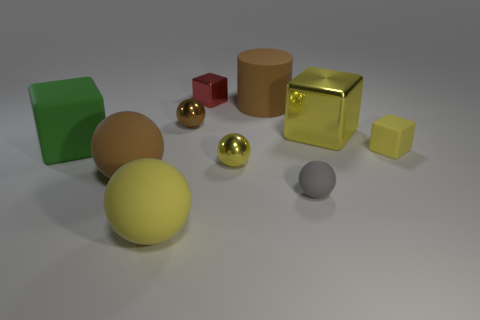Do the large shiny thing and the small rubber block have the same color?
Ensure brevity in your answer.  Yes. There is a brown ball in front of the large green cube; does it have the same size as the brown sphere that is behind the tiny yellow matte thing?
Your answer should be very brief. No. The large block that is on the left side of the small metallic cube is what color?
Provide a succinct answer. Green. What is the material of the large yellow object that is behind the yellow object that is to the left of the red thing?
Provide a succinct answer. Metal. The big metallic object has what shape?
Provide a succinct answer. Cube. What is the material of the small yellow thing that is the same shape as the big green rubber thing?
Your answer should be compact. Rubber. What number of metallic objects have the same size as the brown matte cylinder?
Offer a very short reply. 1. There is a yellow thing that is left of the small brown metallic ball; is there a rubber thing that is to the right of it?
Offer a terse response. Yes. What number of red objects are large spheres or tiny spheres?
Offer a very short reply. 0. What is the color of the tiny shiny cube?
Make the answer very short. Red. 